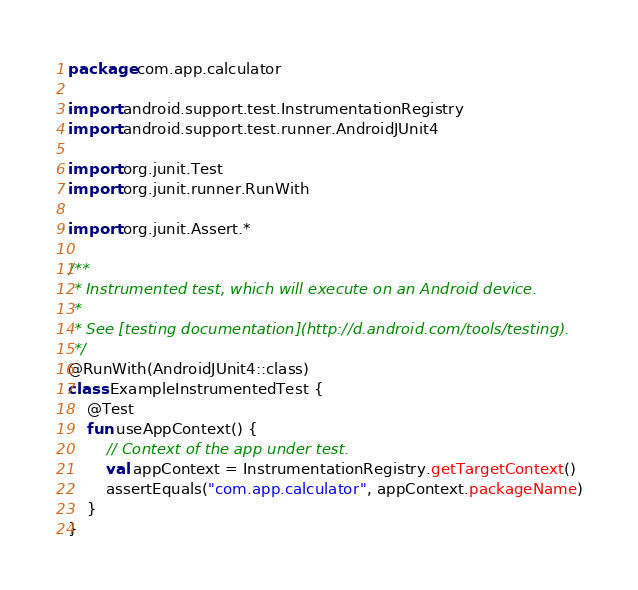Convert code to text. <code><loc_0><loc_0><loc_500><loc_500><_Kotlin_>package com.app.calculator

import android.support.test.InstrumentationRegistry
import android.support.test.runner.AndroidJUnit4

import org.junit.Test
import org.junit.runner.RunWith

import org.junit.Assert.*

/**
 * Instrumented test, which will execute on an Android device.
 *
 * See [testing documentation](http://d.android.com/tools/testing).
 */
@RunWith(AndroidJUnit4::class)
class ExampleInstrumentedTest {
    @Test
    fun useAppContext() {
        // Context of the app under test.
        val appContext = InstrumentationRegistry.getTargetContext()
        assertEquals("com.app.calculator", appContext.packageName)
    }
}
</code> 